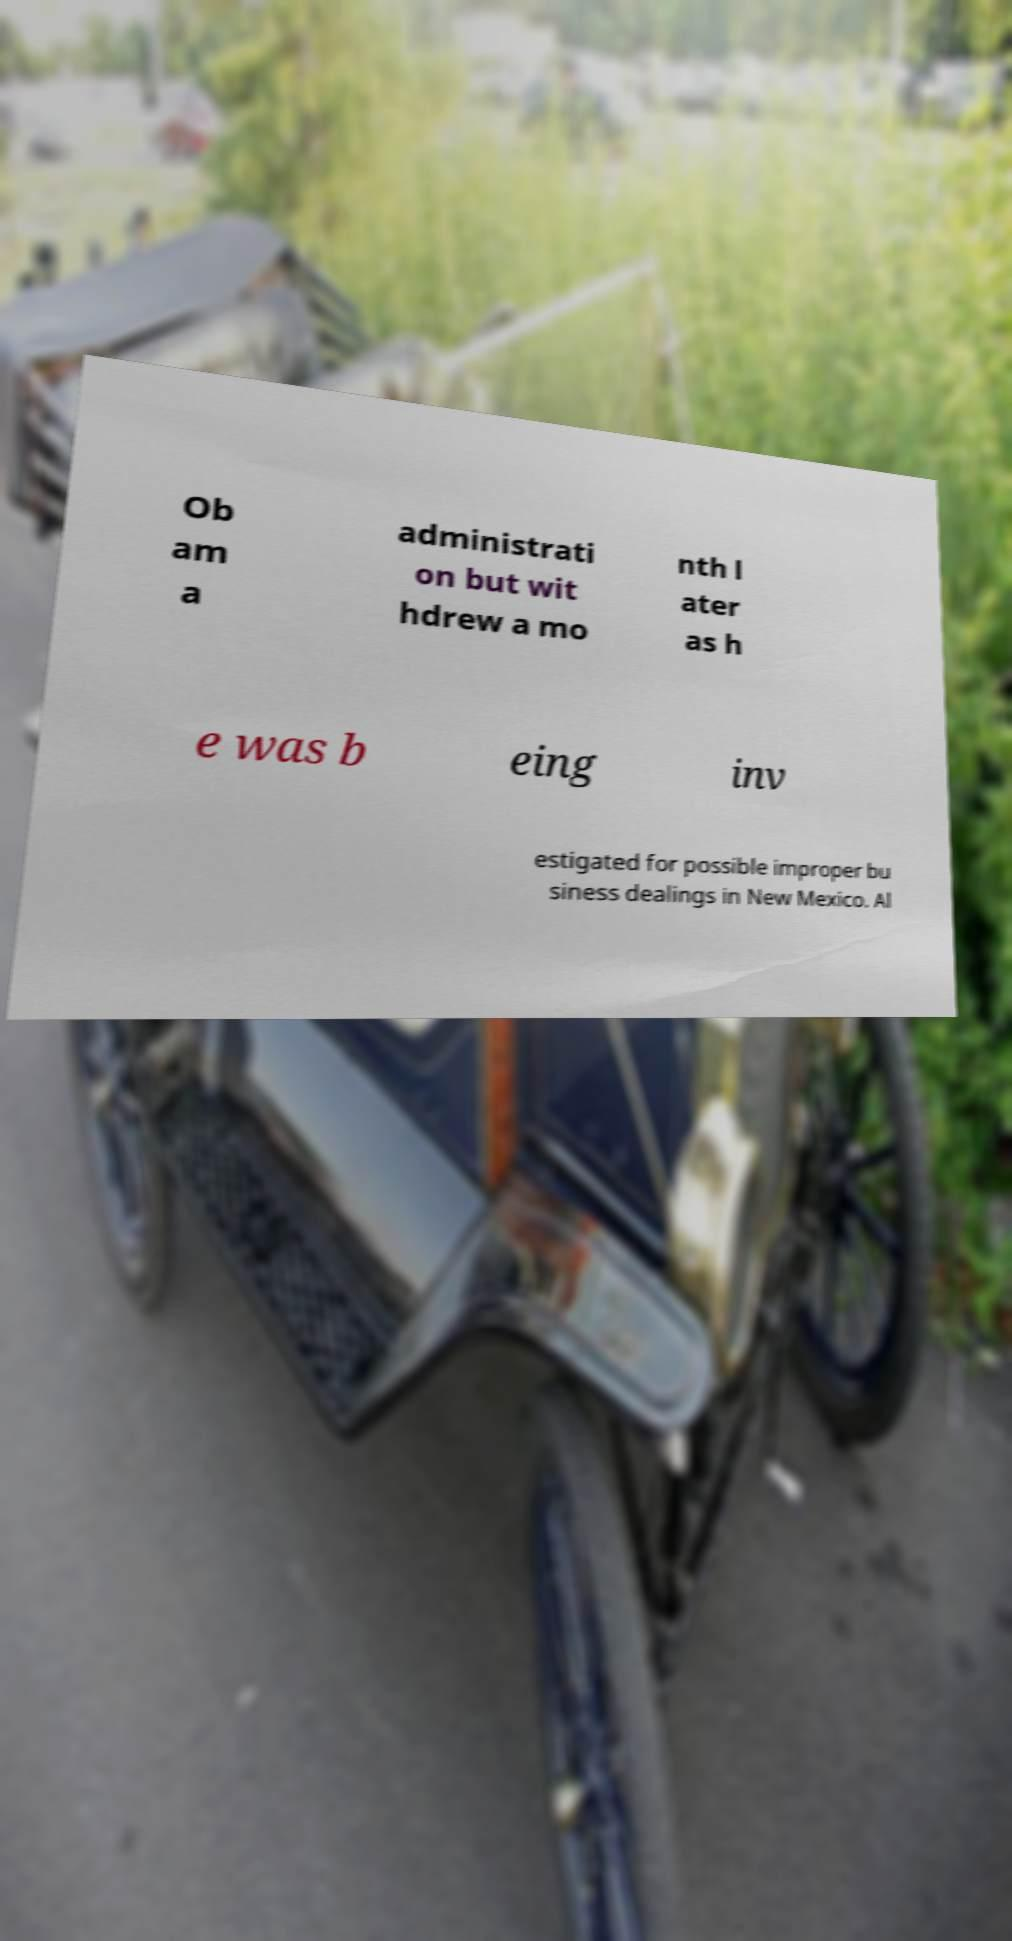Could you assist in decoding the text presented in this image and type it out clearly? Ob am a administrati on but wit hdrew a mo nth l ater as h e was b eing inv estigated for possible improper bu siness dealings in New Mexico. Al 